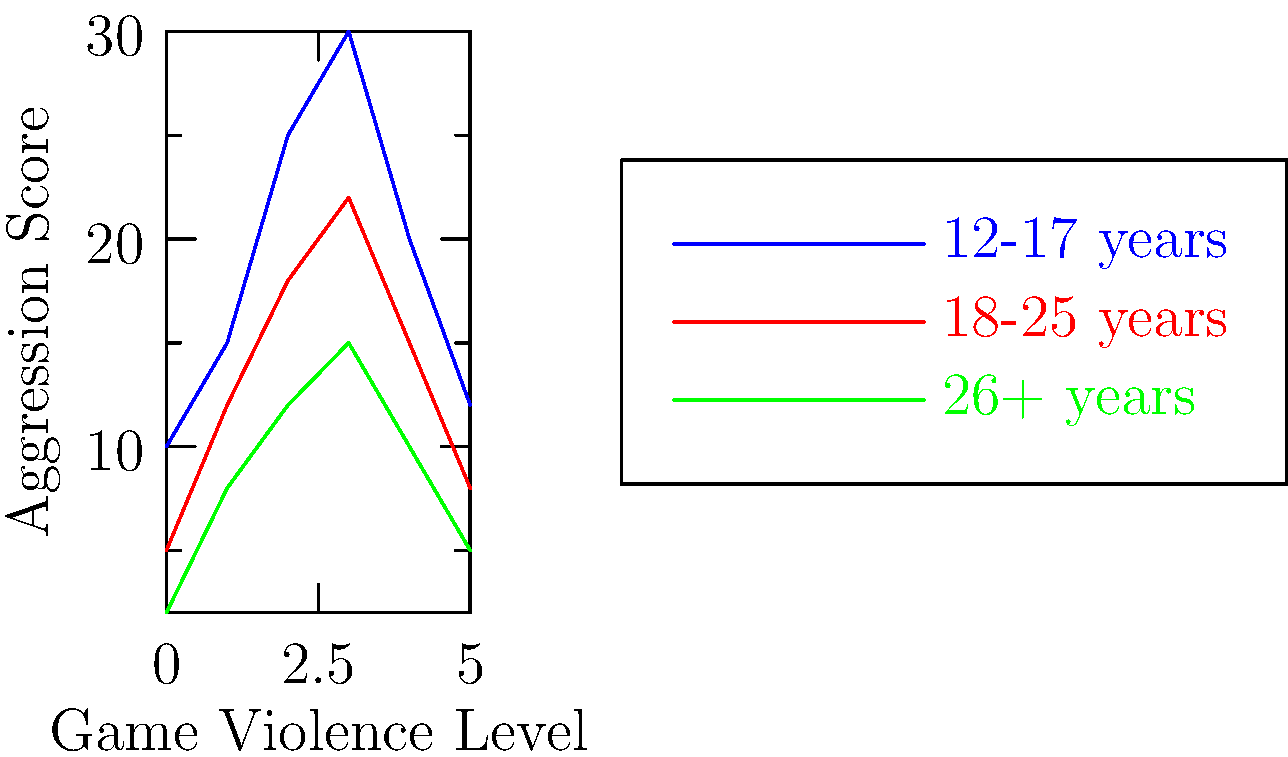Based on the graph showing the relationship between video game violence levels and aggression scores across different age groups, which of the following conclusions is most supported by the data?

A) Violent video games have no significant impact on aggressive behavior across all age groups.
B) The impact of violent video games on aggression is most pronounced in the 12-17 age group.
C) Adults over 26 are more susceptible to aggression from violent video games than younger players.
D) The relationship between game violence and aggression is linear for all age groups. To answer this question, let's analyze the graph step-by-step:

1. The graph shows three lines representing different age groups: 12-17 years (blue), 18-25 years (red), and 26+ years (green).

2. The x-axis represents the "Game Violence Level" (increasing from 0 to 5), while the y-axis shows the "Aggression Score."

3. Examining the blue line (12-17 years):
   - It has the highest overall aggression scores across all violence levels.
   - The line shows the steepest increase, particularly between violence levels 1-3.

4. The red line (18-25 years):
   - Shows moderate aggression scores, consistently lower than the 12-17 age group.
   - The increase in aggression is less steep compared to the 12-17 group.

5. The green line (26+ years):
   - Displays the lowest aggression scores across all violence levels.
   - The increase in aggression is the least pronounced among all groups.

6. Comparing the options:
   A) is incorrect because the graph clearly shows an increase in aggression scores as game violence levels increase for all age groups.
   C) is incorrect as the 26+ age group consistently shows the lowest aggression scores.
   D) is incorrect because the relationships are not perfectly linear, showing varying rates of increase at different points.

7. Option B) aligns most closely with the data, as the 12-17 age group shows the highest aggression scores and the most pronounced increase in aggression as game violence levels rise.

Therefore, the conclusion most supported by the data is that the impact of violent video games on aggression is most pronounced in the 12-17 age group.
Answer: B) The impact of violent video games on aggression is most pronounced in the 12-17 age group. 